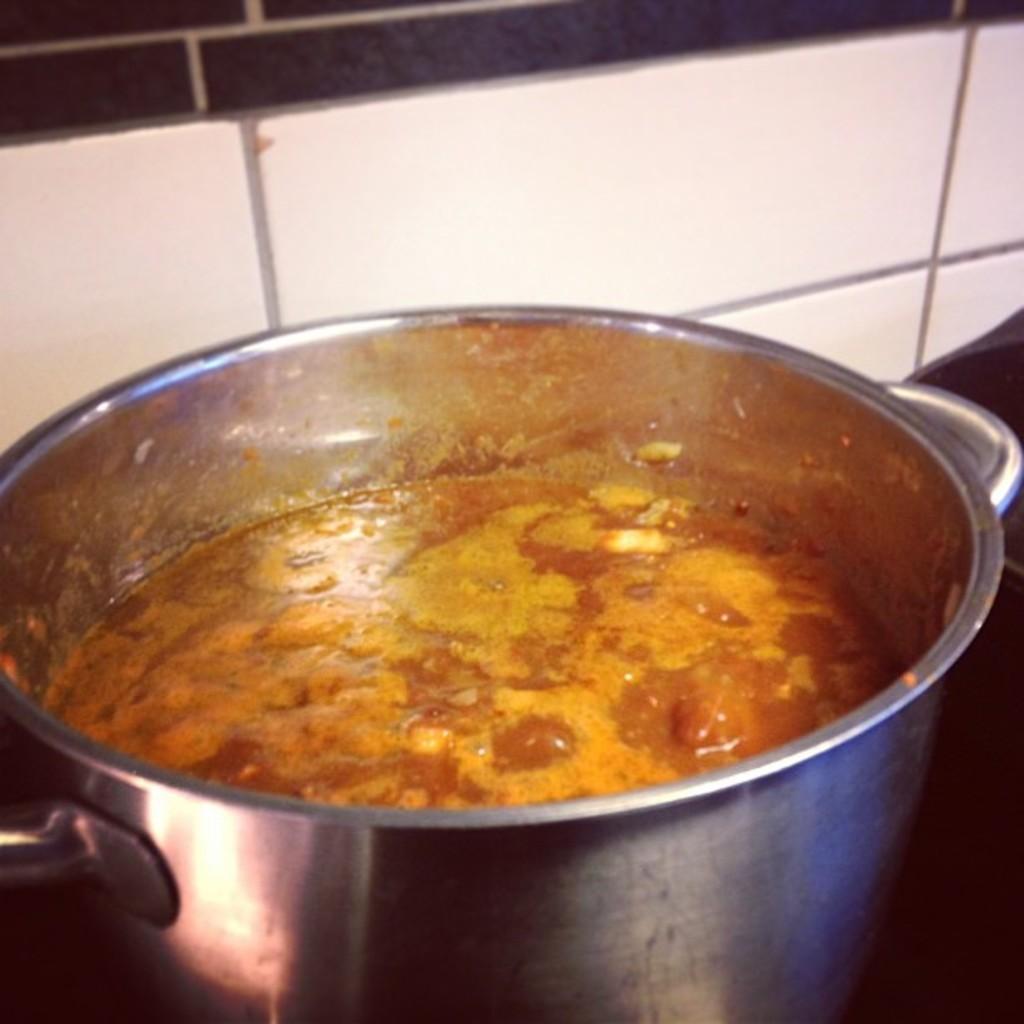In one or two sentences, can you explain what this image depicts? In this picture we can see liquid in the cooking vessel. We can see the tile wall in the background. 